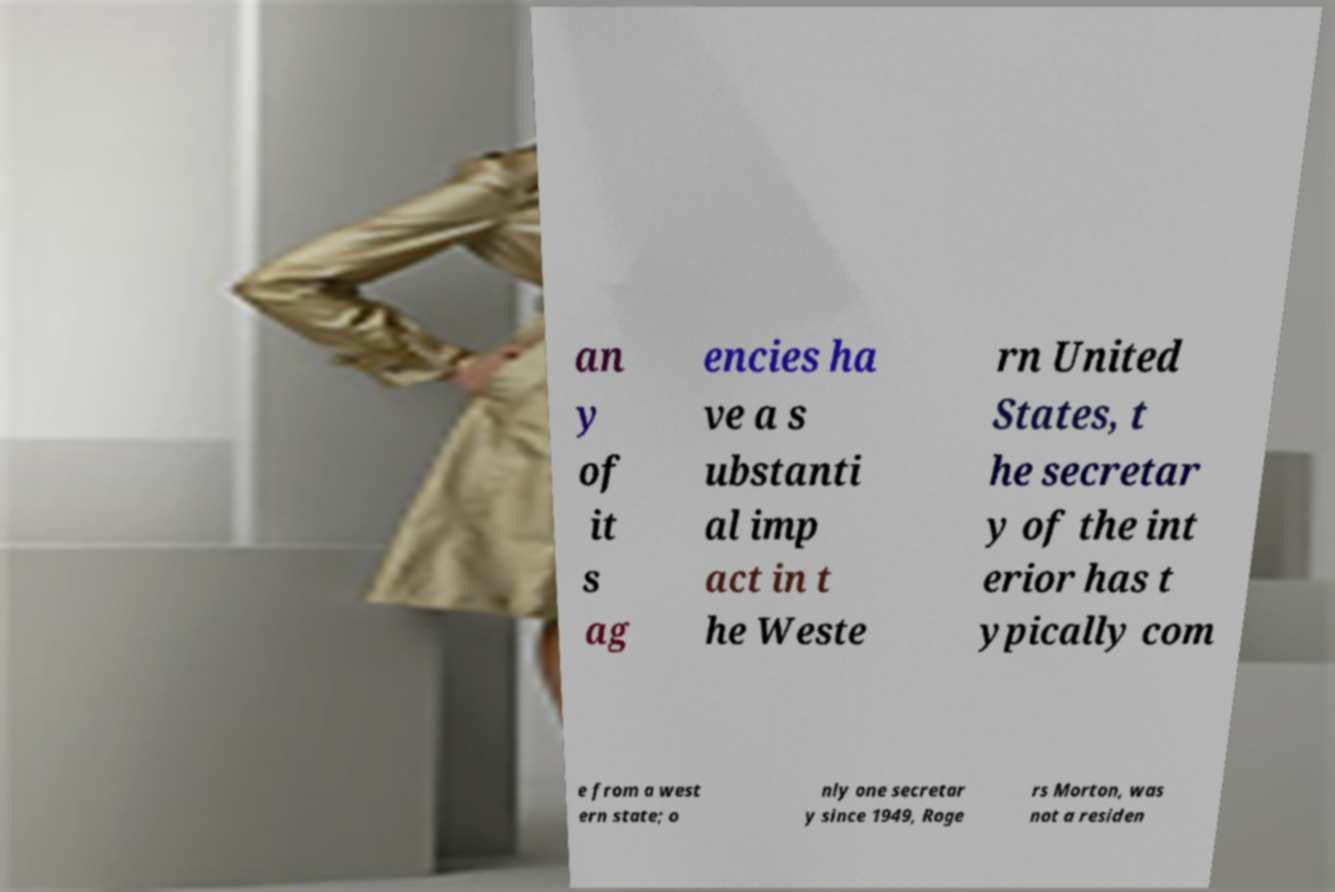Could you extract and type out the text from this image? an y of it s ag encies ha ve a s ubstanti al imp act in t he Weste rn United States, t he secretar y of the int erior has t ypically com e from a west ern state; o nly one secretar y since 1949, Roge rs Morton, was not a residen 